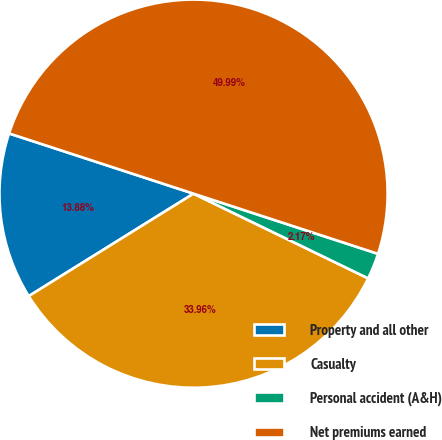Convert chart to OTSL. <chart><loc_0><loc_0><loc_500><loc_500><pie_chart><fcel>Property and all other<fcel>Casualty<fcel>Personal accident (A&H)<fcel>Net premiums earned<nl><fcel>13.88%<fcel>33.96%<fcel>2.17%<fcel>50.0%<nl></chart> 